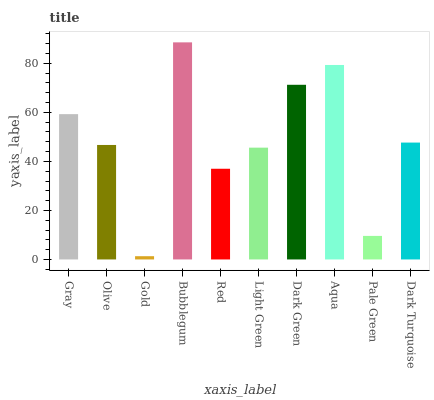Is Gold the minimum?
Answer yes or no. Yes. Is Bubblegum the maximum?
Answer yes or no. Yes. Is Olive the minimum?
Answer yes or no. No. Is Olive the maximum?
Answer yes or no. No. Is Gray greater than Olive?
Answer yes or no. Yes. Is Olive less than Gray?
Answer yes or no. Yes. Is Olive greater than Gray?
Answer yes or no. No. Is Gray less than Olive?
Answer yes or no. No. Is Dark Turquoise the high median?
Answer yes or no. Yes. Is Olive the low median?
Answer yes or no. Yes. Is Bubblegum the high median?
Answer yes or no. No. Is Dark Green the low median?
Answer yes or no. No. 